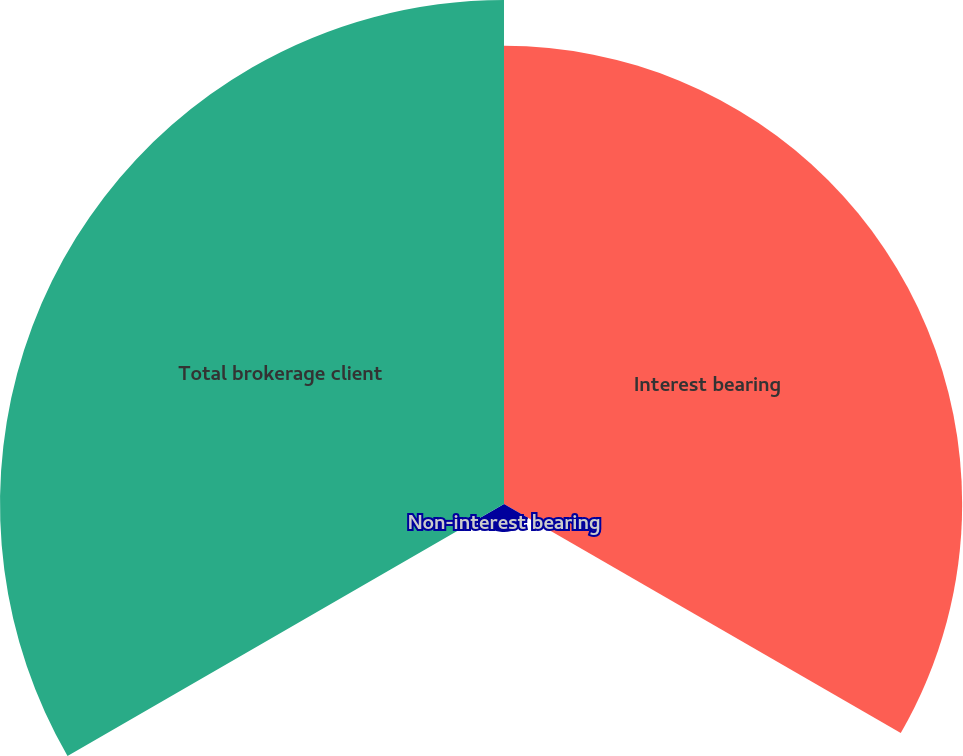Convert chart. <chart><loc_0><loc_0><loc_500><loc_500><pie_chart><fcel>Interest bearing<fcel>Non-interest bearing<fcel>Total brokerage client<nl><fcel>46.27%<fcel>2.83%<fcel>50.9%<nl></chart> 